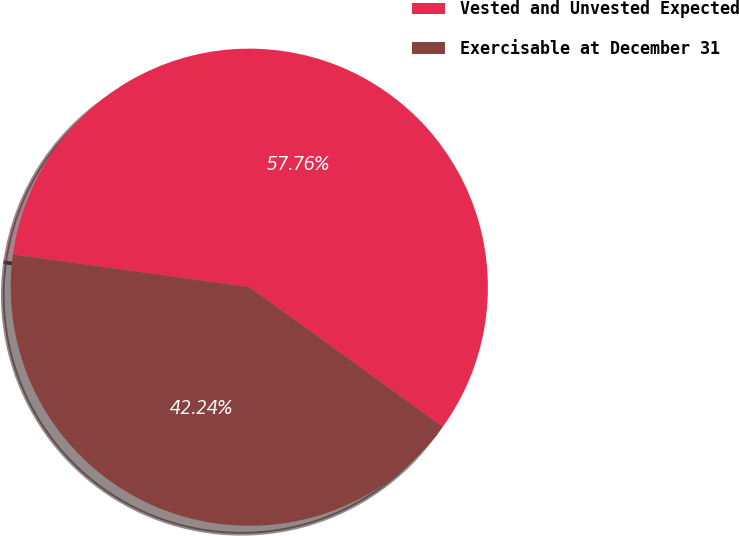Convert chart to OTSL. <chart><loc_0><loc_0><loc_500><loc_500><pie_chart><fcel>Vested and Unvested Expected<fcel>Exercisable at December 31<nl><fcel>57.76%<fcel>42.24%<nl></chart> 